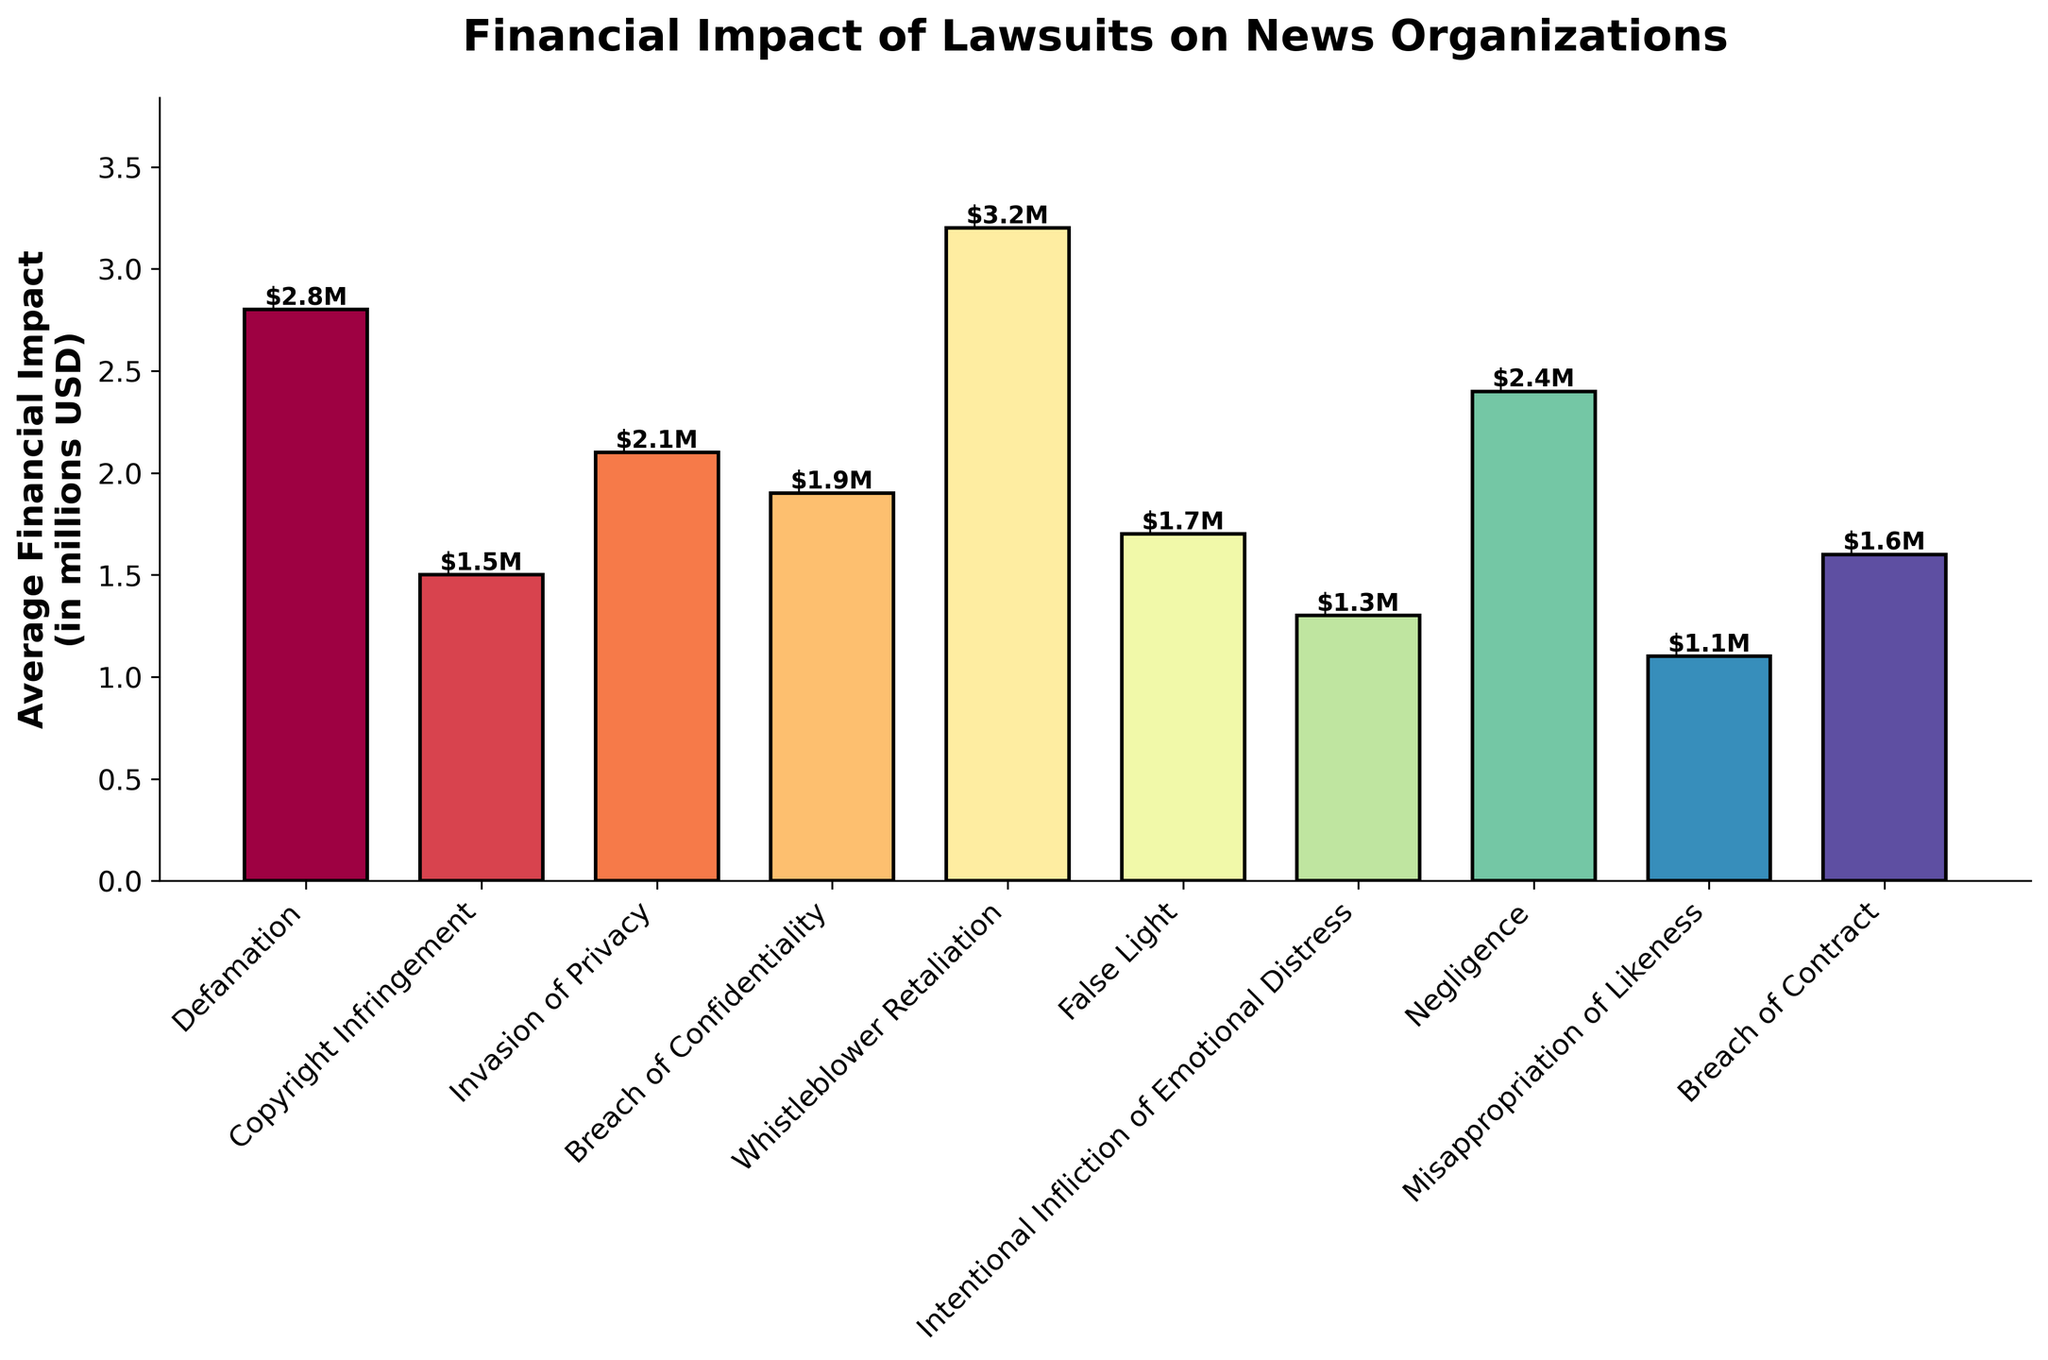What's the type of legal challenge that causes the highest average financial impact? To find the answer, look at the bar with the greatest height in the figure. The tallest bar represents the highest average financial impact.
Answer: Whistleblower Retaliation Which legal challenge has a lower average financial impact, Copyright Infringement or False Light? Compare the heights of the bars representing Copyright Infringement and False Light. The one with the smaller height has the lower average financial impact.
Answer: False Light What is the combined average financial impact of Defamation and Negligence? Locate the bars for Defamation and Negligence. Add their heights (financial impacts): 2.8 (Defamation) + 2.4 (Negligence).
Answer: 5.2 million USD Is the average financial impact of Invasion of Privacy greater than Breach of Confidentiality? Compare the heights of the bars for Invasion of Privacy and Breach of Confidentiality. Determine if the height of Invasion of Privacy is higher.
Answer: Yes What's the difference in average financial impact between the highest and lowest legal challenge categories? Identify the highest and lowest average financial impact bars (Whistleblower Retaliation and Misappropriation of Likeness, respectively). Subtract the minimum height from the maximum height: 3.2 (highest) - 1.1 (lowest).
Answer: 2.1 million USD What is the median average financial impact among all legal challenges? List all average financial impacts and sort them: [1.1, 1.3, 1.5, 1.6, 1.7, 1.9, 2.1, 2.4, 2.8, 3.2]. Find the middle value in this sorted list; with 10 values, the median is the average of the 5th and 6th values: (1.7 + 1.9)/2.
Answer: 1.8 million USD Are there more legal challenges with an average financial impact above 2 million USD or below it? Count the number of bars that exceed 2 million USD and those below it. Those above 2 million USD are: Defamation, Negligence, Invasion of Privacy, and Whistleblower Retaliation. Those below are: Copyright Infringement, False Light, Intentional Infliction of Emotional Distress, Misappropriation of Likeness, Breach of Confidentiality, and Breach of Contract. Compare the counts: 4 above and 6 below.
Answer: Below By how much does the average financial impact of Negligence exceed that of Intentional Infliction of Emotional Distress? Find and compare the bar heights for Negligence and Intentional Infliction of Emotional Distress: 2.4 (Negligence) - 1.3 (Intentional Infliction of Emotional Distress).
Answer: 1.1 million USD 